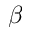Convert formula to latex. <formula><loc_0><loc_0><loc_500><loc_500>\beta</formula> 